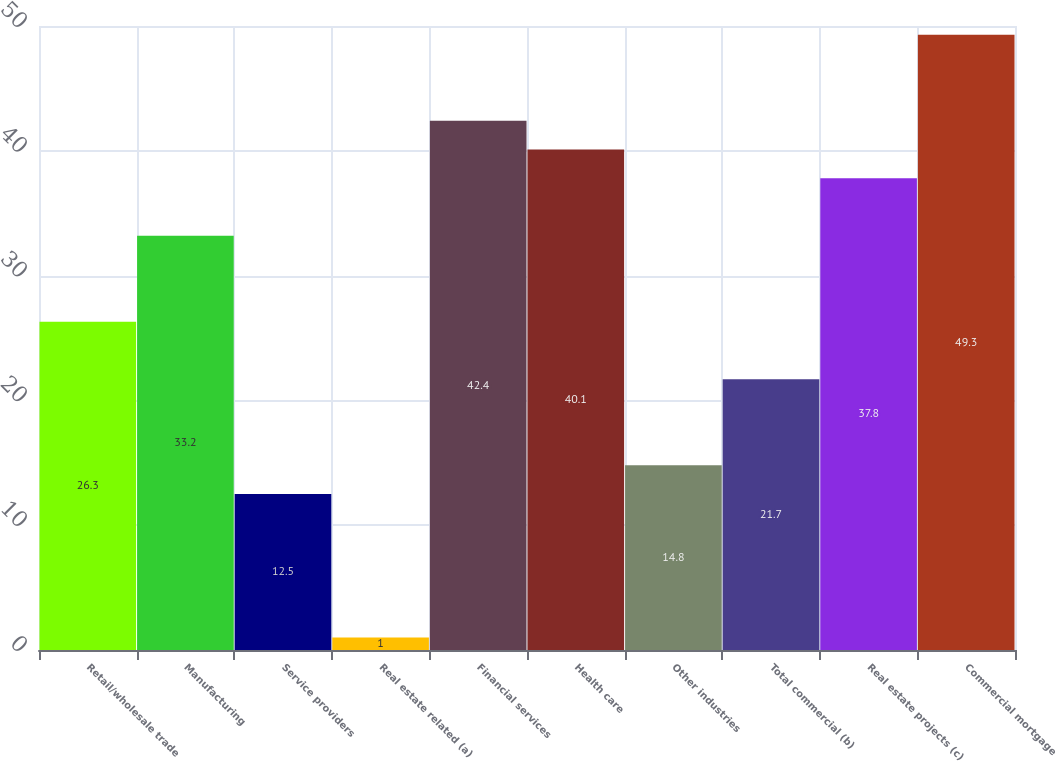Convert chart to OTSL. <chart><loc_0><loc_0><loc_500><loc_500><bar_chart><fcel>Retail/wholesale trade<fcel>Manufacturing<fcel>Service providers<fcel>Real estate related (a)<fcel>Financial services<fcel>Health care<fcel>Other industries<fcel>Total commercial (b)<fcel>Real estate projects (c)<fcel>Commercial mortgage<nl><fcel>26.3<fcel>33.2<fcel>12.5<fcel>1<fcel>42.4<fcel>40.1<fcel>14.8<fcel>21.7<fcel>37.8<fcel>49.3<nl></chart> 